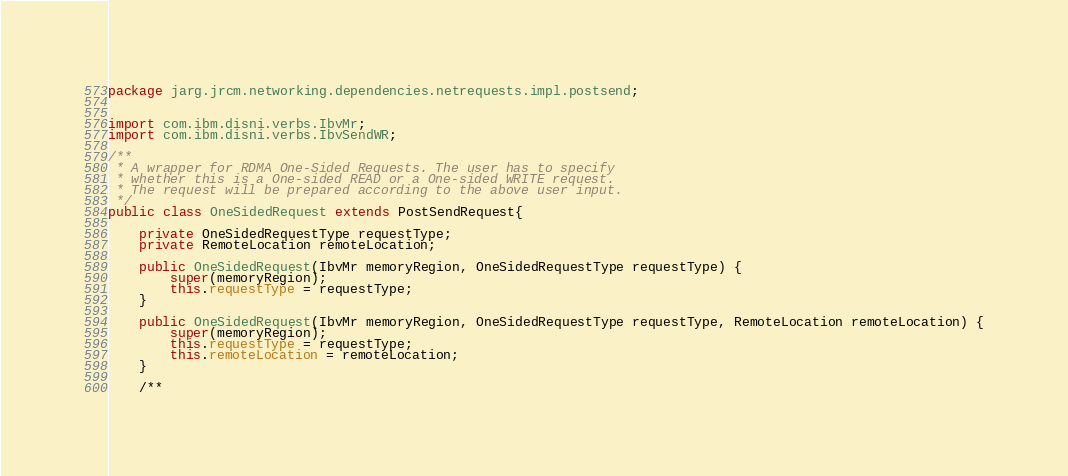Convert code to text. <code><loc_0><loc_0><loc_500><loc_500><_Java_>package jarg.jrcm.networking.dependencies.netrequests.impl.postsend;


import com.ibm.disni.verbs.IbvMr;
import com.ibm.disni.verbs.IbvSendWR;

/**
 * A wrapper for RDMA One-Sided Requests. The user has to specify
 * whether this is a One-sided READ or a One-sided WRITE request.
 * The request will be prepared according to the above user input.
 */
public class OneSidedRequest extends PostSendRequest{

    private OneSidedRequestType requestType;
    private RemoteLocation remoteLocation;

    public OneSidedRequest(IbvMr memoryRegion, OneSidedRequestType requestType) {
        super(memoryRegion);
        this.requestType = requestType;
    }

    public OneSidedRequest(IbvMr memoryRegion, OneSidedRequestType requestType, RemoteLocation remoteLocation) {
        super(memoryRegion);
        this.requestType = requestType;
        this.remoteLocation = remoteLocation;
    }

    /**</code> 